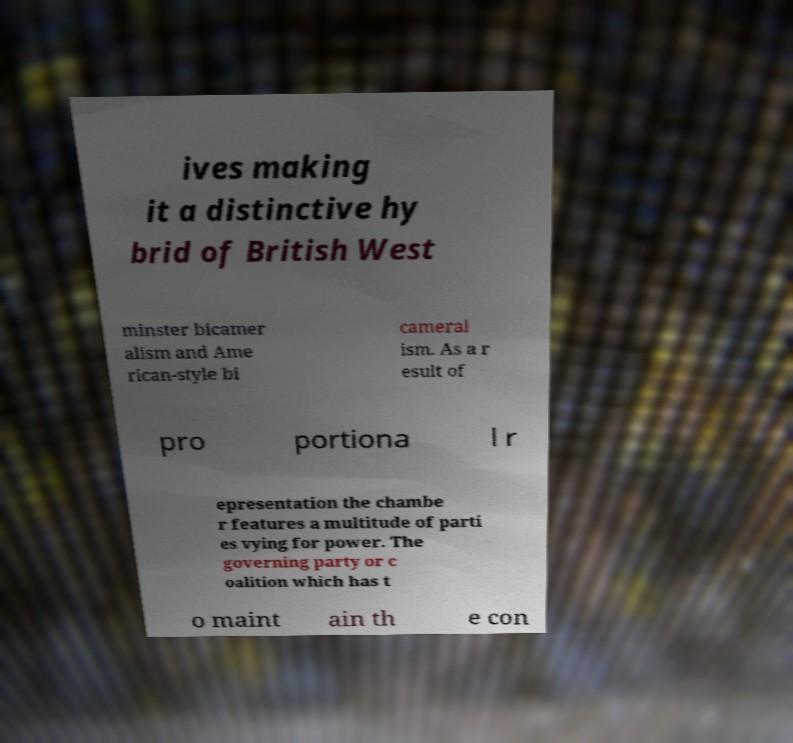Can you read and provide the text displayed in the image?This photo seems to have some interesting text. Can you extract and type it out for me? ives making it a distinctive hy brid of British West minster bicamer alism and Ame rican-style bi cameral ism. As a r esult of pro portiona l r epresentation the chambe r features a multitude of parti es vying for power. The governing party or c oalition which has t o maint ain th e con 